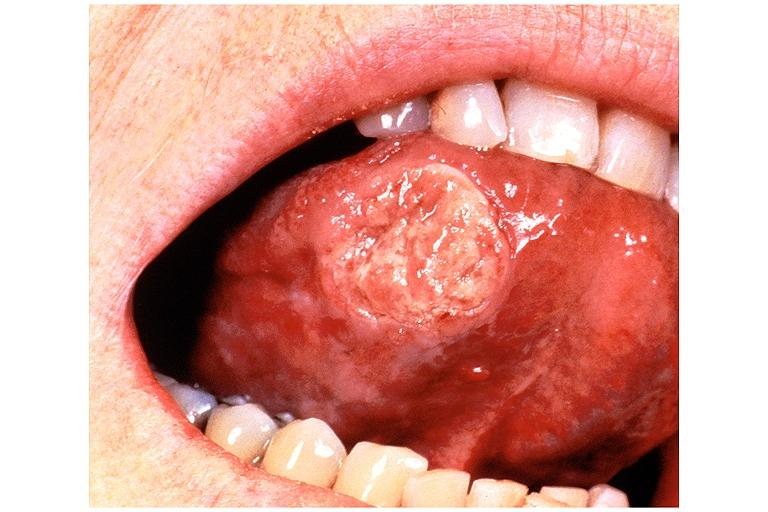what is present?
Answer the question using a single word or phrase. Oral 